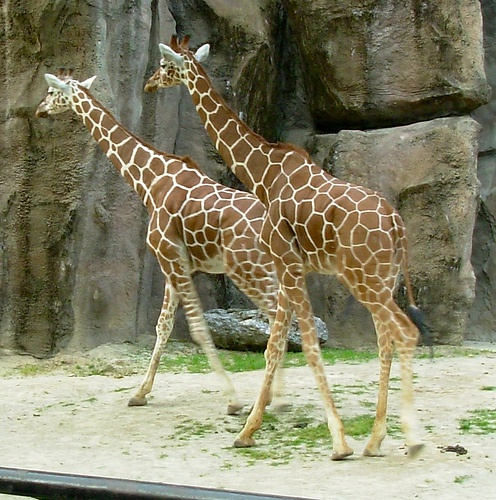Describe the objects in this image and their specific colors. I can see giraffe in black, olive, tan, gray, and beige tones and giraffe in black, gray, olive, tan, and ivory tones in this image. 